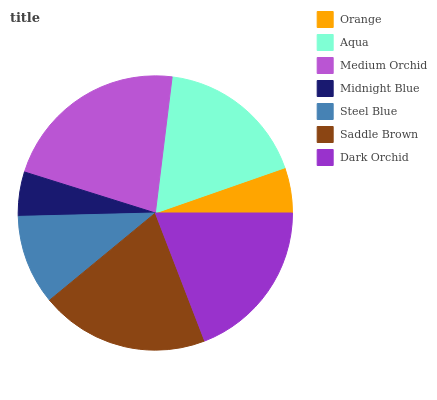Is Midnight Blue the minimum?
Answer yes or no. Yes. Is Medium Orchid the maximum?
Answer yes or no. Yes. Is Aqua the minimum?
Answer yes or no. No. Is Aqua the maximum?
Answer yes or no. No. Is Aqua greater than Orange?
Answer yes or no. Yes. Is Orange less than Aqua?
Answer yes or no. Yes. Is Orange greater than Aqua?
Answer yes or no. No. Is Aqua less than Orange?
Answer yes or no. No. Is Aqua the high median?
Answer yes or no. Yes. Is Aqua the low median?
Answer yes or no. Yes. Is Steel Blue the high median?
Answer yes or no. No. Is Orange the low median?
Answer yes or no. No. 